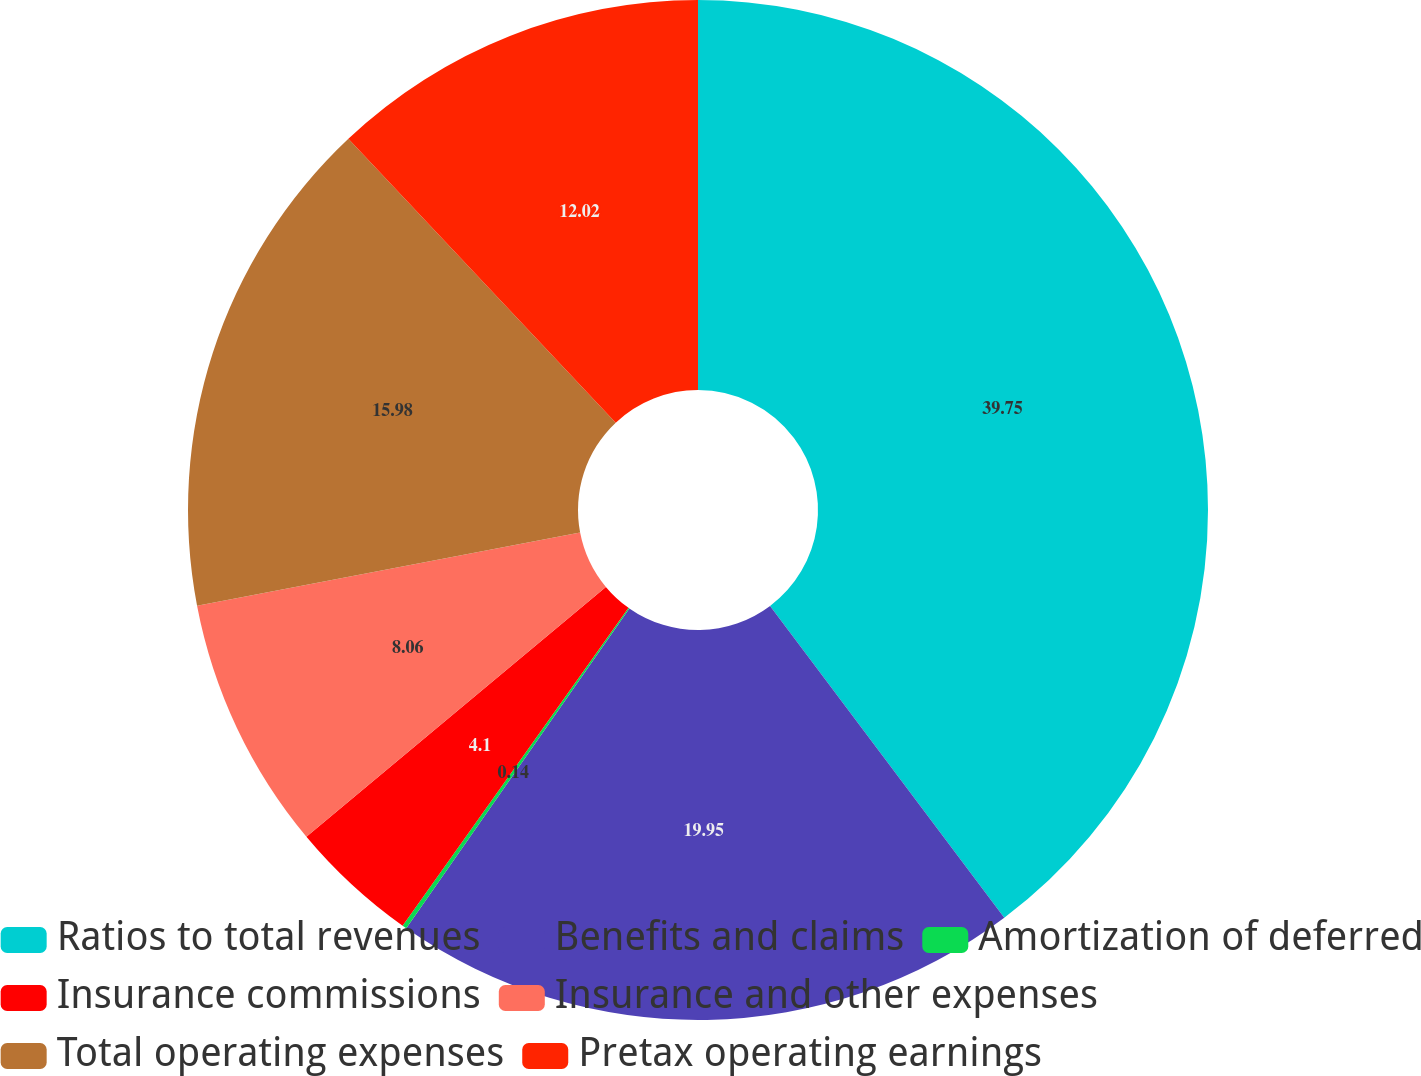Convert chart to OTSL. <chart><loc_0><loc_0><loc_500><loc_500><pie_chart><fcel>Ratios to total revenues<fcel>Benefits and claims<fcel>Amortization of deferred<fcel>Insurance commissions<fcel>Insurance and other expenses<fcel>Total operating expenses<fcel>Pretax operating earnings<nl><fcel>39.74%<fcel>19.94%<fcel>0.14%<fcel>4.1%<fcel>8.06%<fcel>15.98%<fcel>12.02%<nl></chart> 